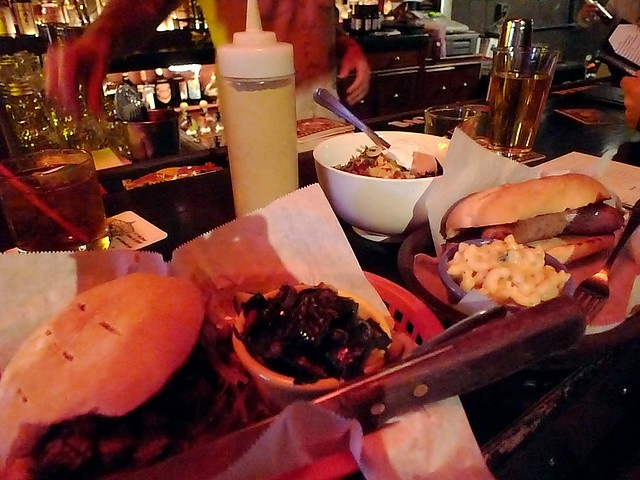Describe the objects in this image and their specific colors. I can see sandwich in maroon, black, red, salmon, and brown tones, dining table in maroon, black, and brown tones, knife in maroon, black, and brown tones, bowl in maroon, black, brown, and red tones, and people in maroon, black, and brown tones in this image. 